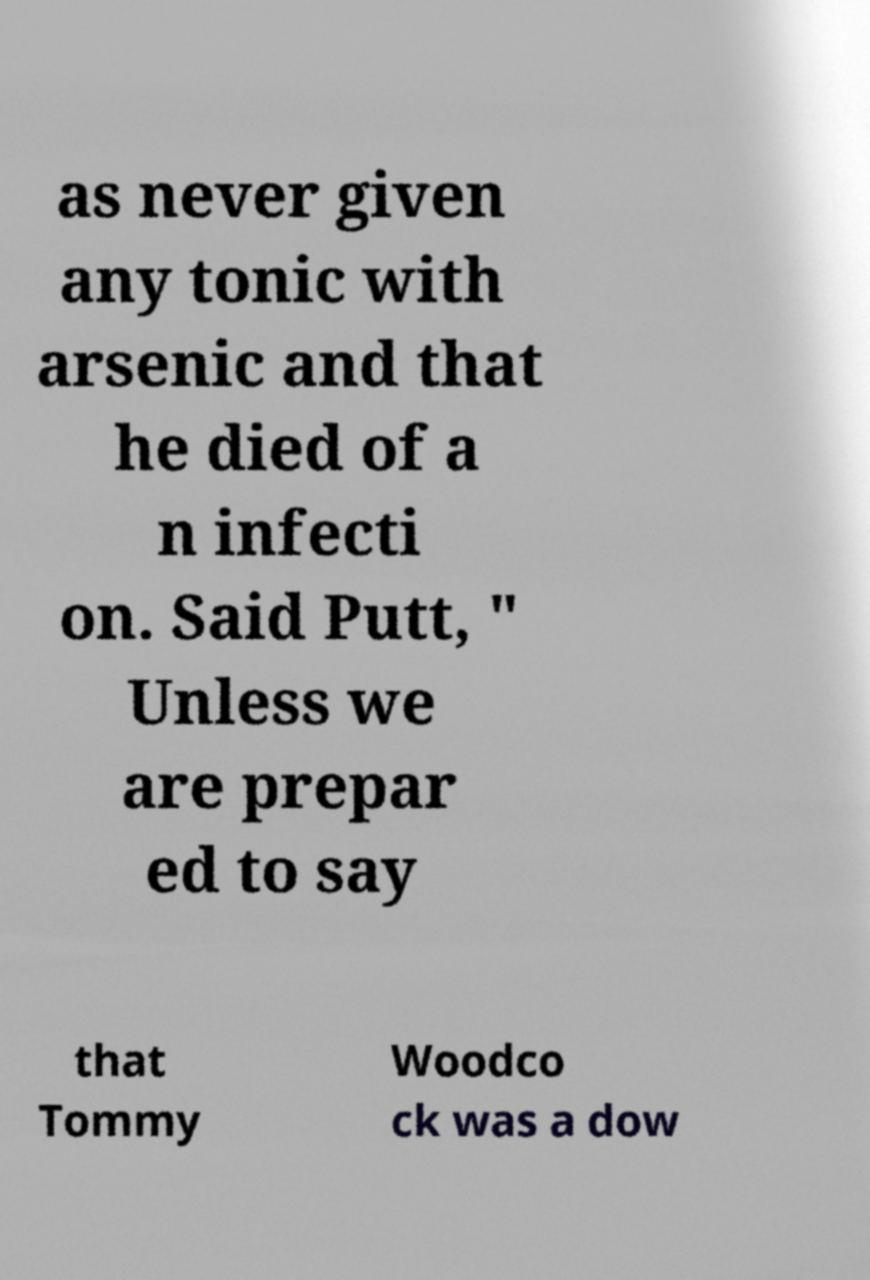Can you accurately transcribe the text from the provided image for me? as never given any tonic with arsenic and that he died of a n infecti on. Said Putt, " Unless we are prepar ed to say that Tommy Woodco ck was a dow 